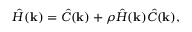<formula> <loc_0><loc_0><loc_500><loc_500>{ \hat { H } } ( k ) = { \hat { C } } ( k ) + \rho { \hat { H } } ( k ) { \hat { C } } ( k ) ,</formula> 